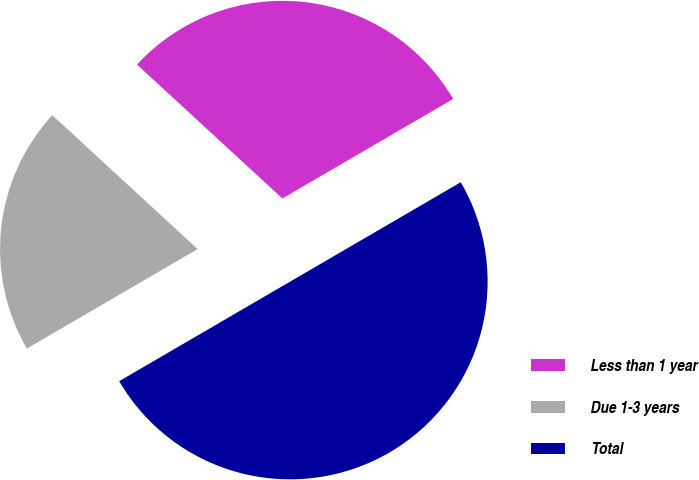<chart> <loc_0><loc_0><loc_500><loc_500><pie_chart><fcel>Less than 1 year<fcel>Due 1-3 years<fcel>Total<nl><fcel>29.76%<fcel>20.24%<fcel>50.0%<nl></chart> 